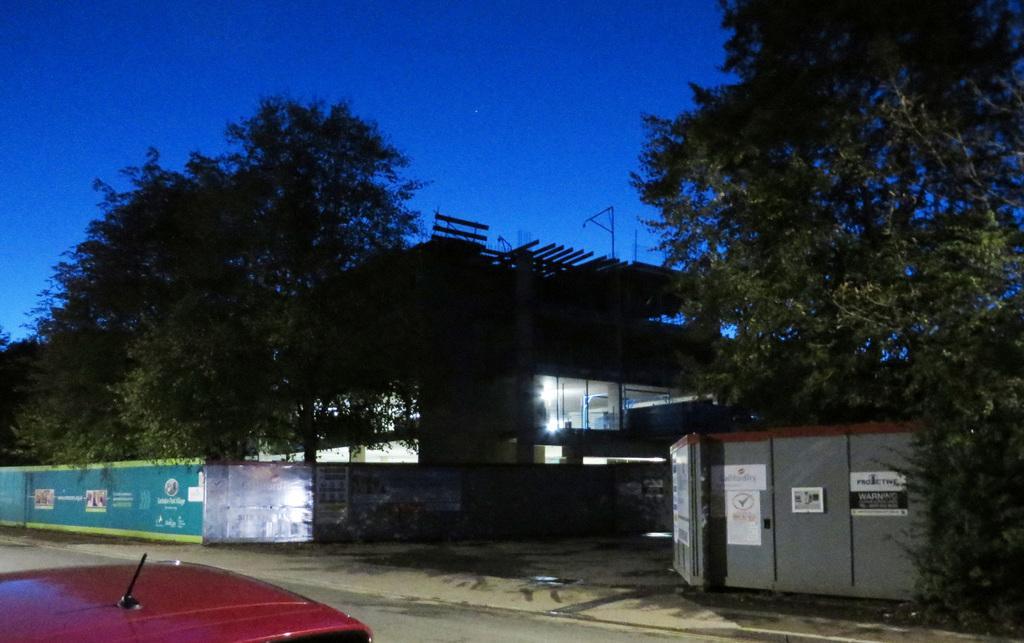In one or two sentences, can you explain what this image depicts? At the bottom of the image, we can see the part of a car. In the background, we can see the sky, trees, lights, one building, road and compound wall. And we can see posts on the wall. 